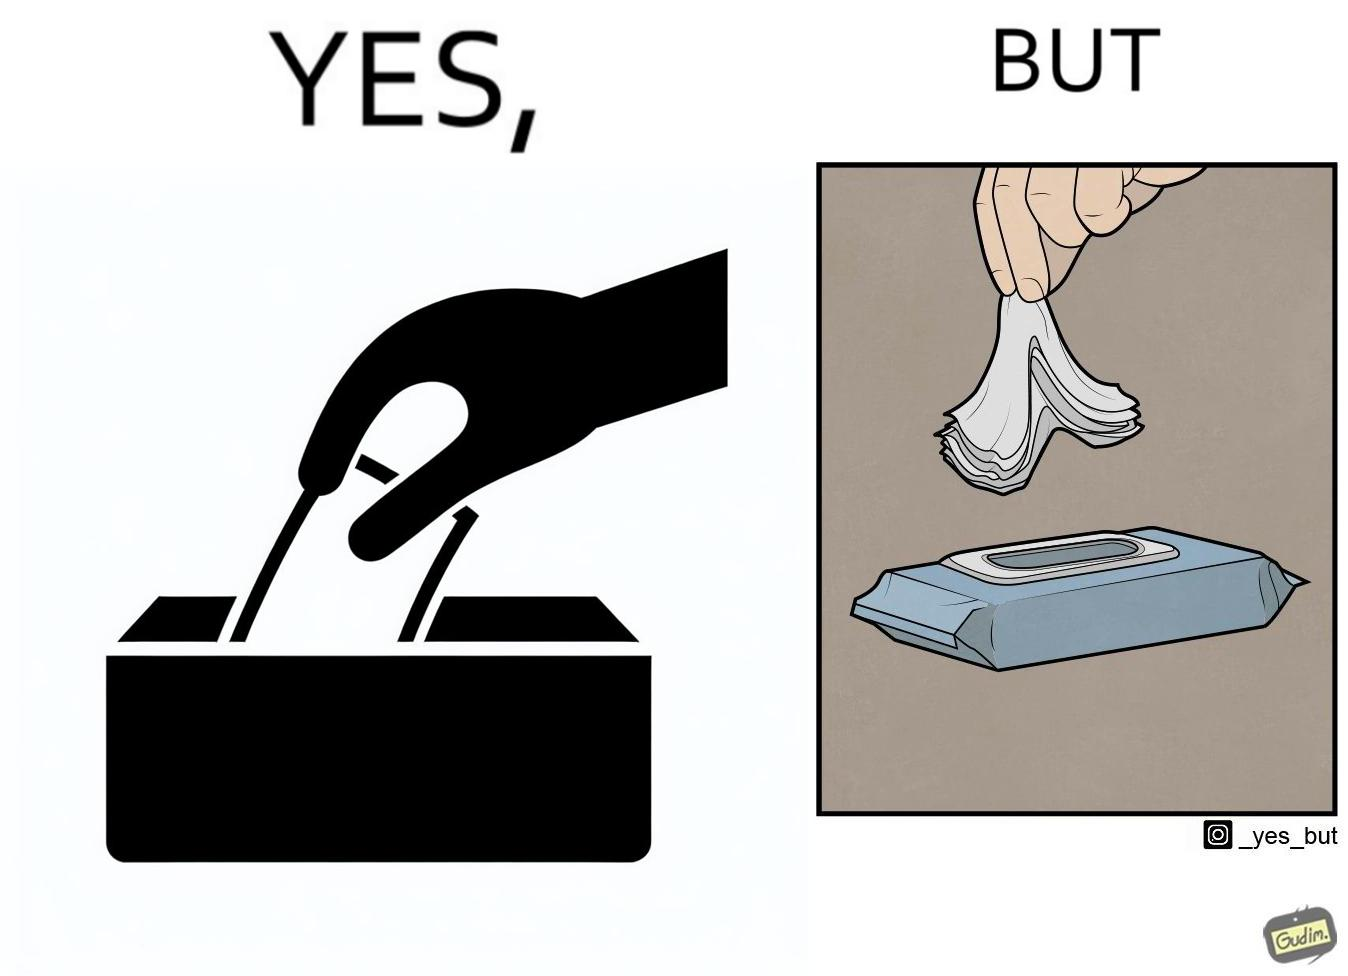Describe what you see in the left and right parts of this image. In the left part of the image: a person pulling out a napkin from the box In the right part of the image: a person pulling many napkin out of a box together 